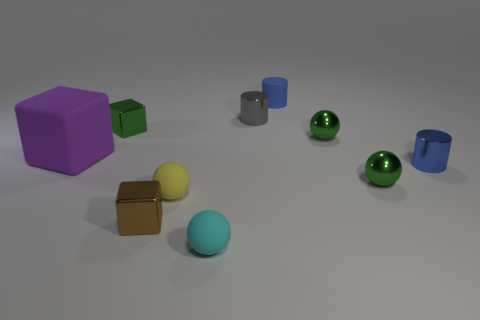How many things are green cubes or small matte cylinders?
Ensure brevity in your answer.  2. Do the yellow object and the small thing that is in front of the tiny brown thing have the same material?
Offer a terse response. Yes. Is there anything else that is the same color as the large object?
Ensure brevity in your answer.  No. What number of things are either blocks in front of the large rubber thing or tiny objects that are to the right of the tiny cyan sphere?
Ensure brevity in your answer.  6. What is the shape of the matte thing that is both on the right side of the small yellow rubber object and behind the tiny brown shiny thing?
Keep it short and to the point. Cylinder. There is a tiny matte sphere to the left of the cyan rubber thing; how many tiny metallic blocks are behind it?
Your response must be concise. 1. Is there anything else that is made of the same material as the large purple object?
Offer a very short reply. Yes. How many things are small green objects that are in front of the tiny green block or big yellow rubber blocks?
Offer a very short reply. 2. There is a sphere left of the small cyan matte thing; what is its size?
Give a very brief answer. Small. What is the yellow object made of?
Ensure brevity in your answer.  Rubber. 